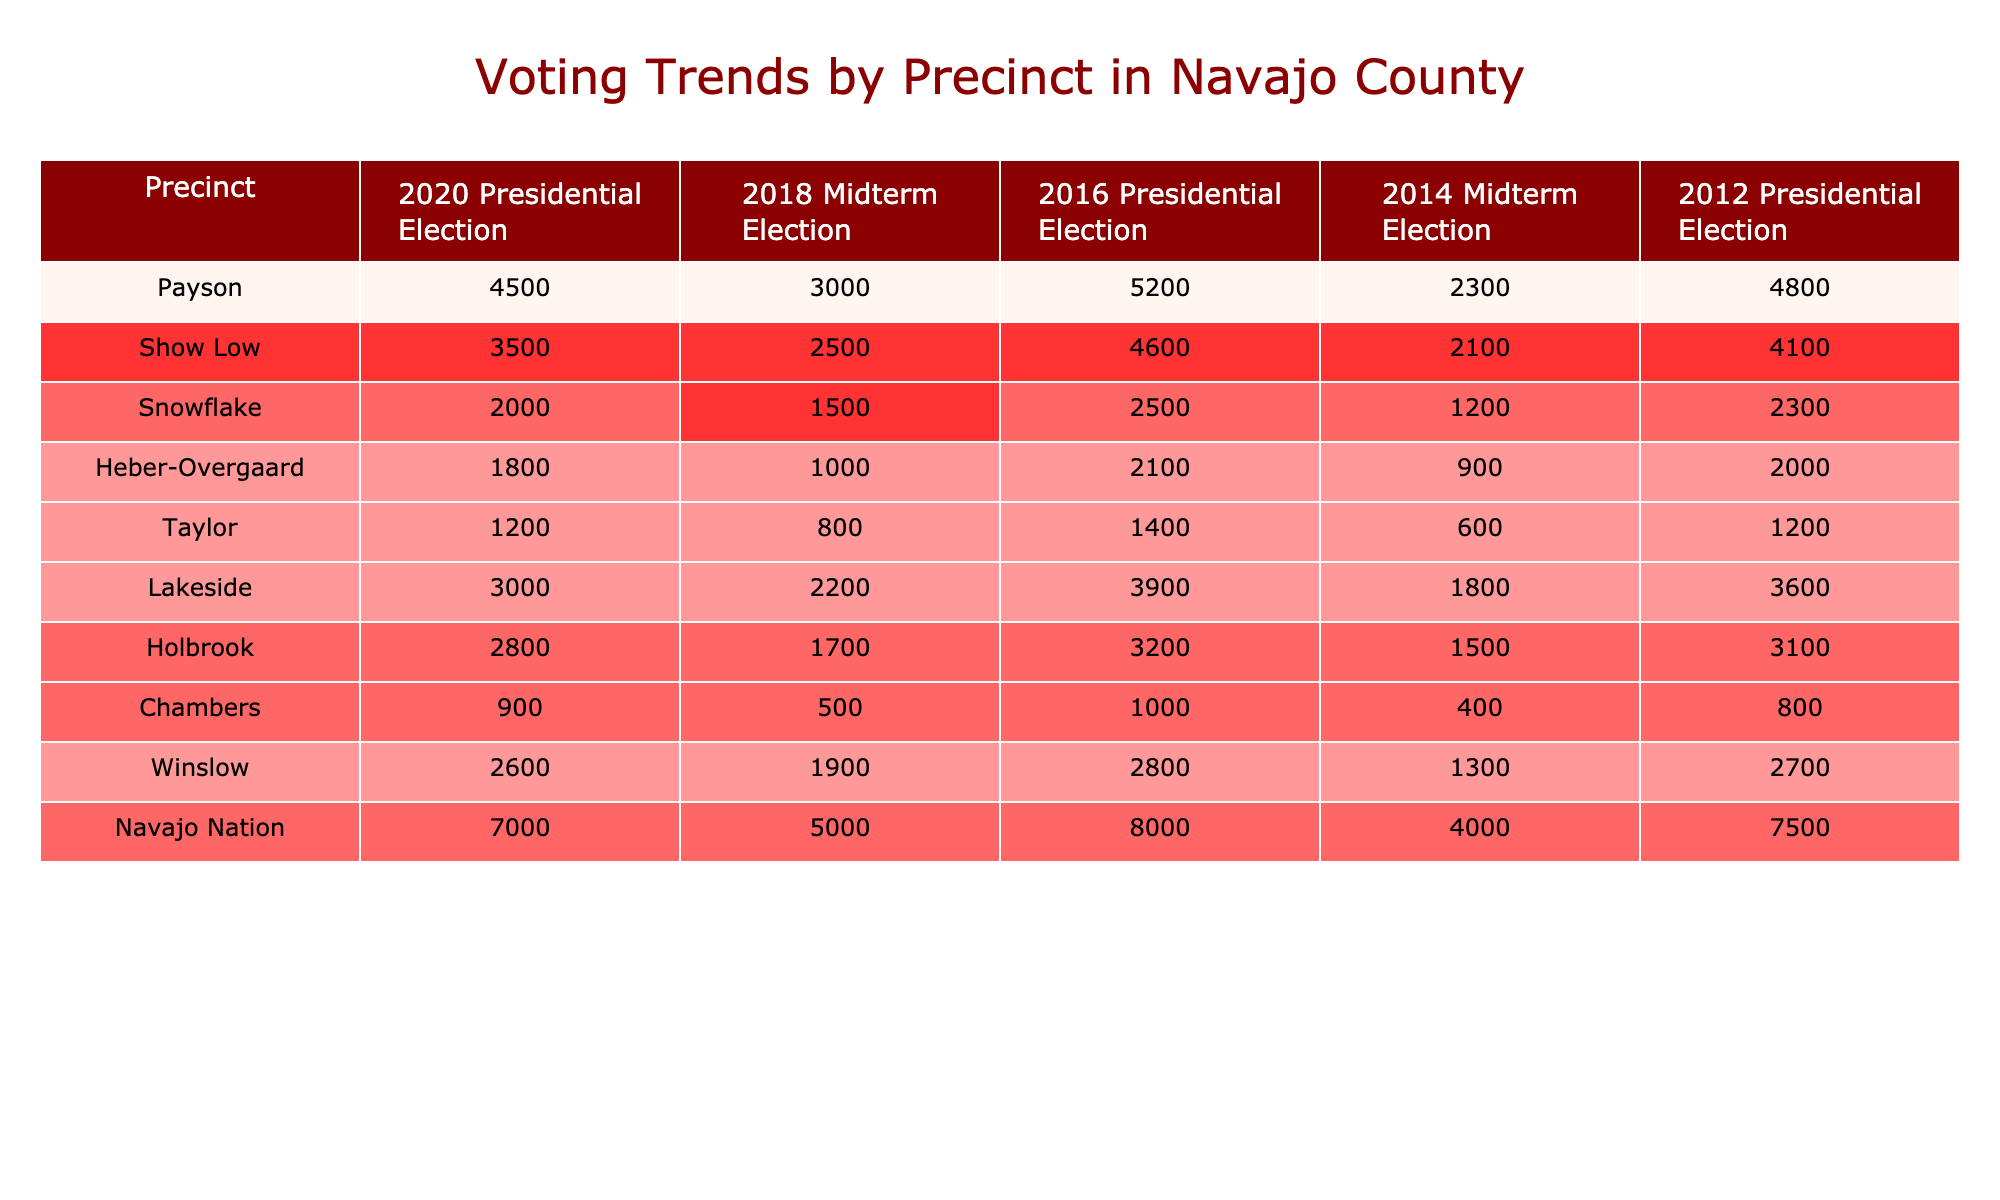What was the highest vote count in the 2020 Presidential Election? Looking at the column for the 2020 Presidential Election, the highest vote count is found in the Navajo Nation row, which shows 7000 votes.
Answer: 7000 Which precinct had the lowest votes in the 2014 Midterm Election? In the 2014 Midterm Election column, the lowest vote count is found in the Taylor row, which shows 600 votes.
Answer: Taylor What is the average number of votes across all precincts for the 2016 Presidential Election? The sum of votes in the 2016 Presidential Election is (5200 + 4600 + 2500 + 2100 + 1400 + 3900 + 3200 + 1000 + 2800 + 8000) =  20000. There are 10 precincts, so the average is 20000/10 = 2000.
Answer: 2000 Did the Payson precinct receive more votes in the 2012 Presidential Election than in the 2014 Midterm Election? In the 2012 Presidential Election, Payson received 4800 votes, and in the 2014 Midterm Election, it received 2300 votes. Since 4800 is greater than 2300, the answer is yes.
Answer: Yes Which precinct had consistent growth in vote count from 2014 to 2020? Looking at the rows, the Navajo Nation precinct shows an increase from 4000 votes in 2014, to 5000 in 2018, and then 7000 in 2020. This shows steady growth over these elections.
Answer: Navajo Nation 